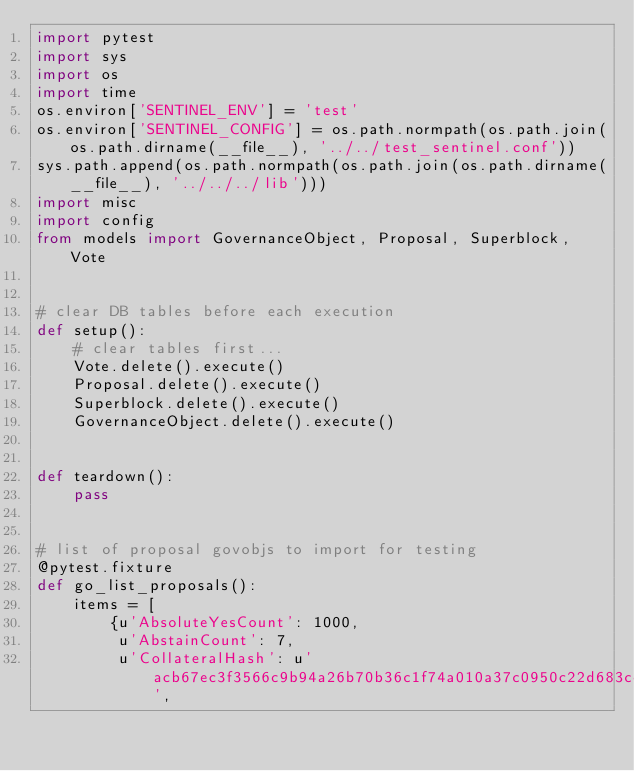Convert code to text. <code><loc_0><loc_0><loc_500><loc_500><_Python_>import pytest
import sys
import os
import time
os.environ['SENTINEL_ENV'] = 'test'
os.environ['SENTINEL_CONFIG'] = os.path.normpath(os.path.join(os.path.dirname(__file__), '../../test_sentinel.conf'))
sys.path.append(os.path.normpath(os.path.join(os.path.dirname(__file__), '../../../lib')))
import misc
import config
from models import GovernanceObject, Proposal, Superblock, Vote


# clear DB tables before each execution
def setup():
    # clear tables first...
    Vote.delete().execute()
    Proposal.delete().execute()
    Superblock.delete().execute()
    GovernanceObject.delete().execute()


def teardown():
    pass


# list of proposal govobjs to import for testing
@pytest.fixture
def go_list_proposals():
    items = [
        {u'AbsoluteYesCount': 1000,
         u'AbstainCount': 7,
         u'CollateralHash': u'acb67ec3f3566c9b94a26b70b36c1f74a010a37c0950c22d683cc50da324fdca',</code> 